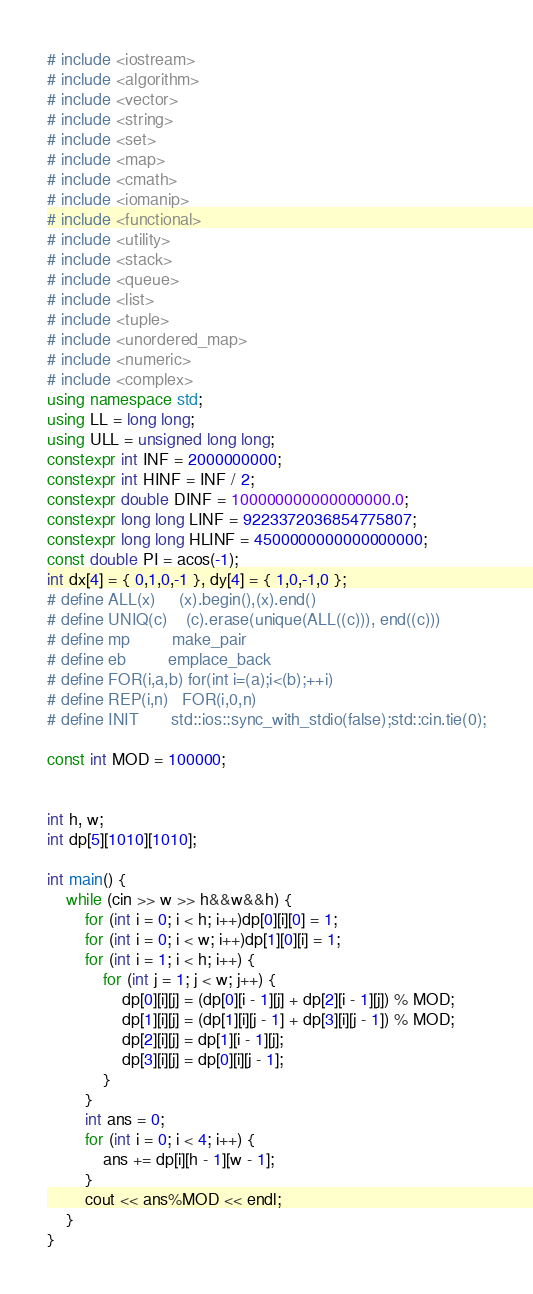Convert code to text. <code><loc_0><loc_0><loc_500><loc_500><_C++_># include <iostream>
# include <algorithm>
# include <vector>
# include <string>
# include <set>
# include <map>
# include <cmath>
# include <iomanip>
# include <functional>
# include <utility>
# include <stack>
# include <queue>
# include <list>
# include <tuple>
# include <unordered_map>
# include <numeric>
# include <complex>
using namespace std;
using LL = long long;
using ULL = unsigned long long;
constexpr int INF = 2000000000;
constexpr int HINF = INF / 2;
constexpr double DINF = 100000000000000000.0;
constexpr long long LINF = 9223372036854775807;
constexpr long long HLINF = 4500000000000000000;
const double PI = acos(-1);
int dx[4] = { 0,1,0,-1 }, dy[4] = { 1,0,-1,0 };
# define ALL(x)     (x).begin(),(x).end()
# define UNIQ(c)    (c).erase(unique(ALL((c))), end((c)))
# define mp         make_pair
# define eb         emplace_back
# define FOR(i,a,b) for(int i=(a);i<(b);++i)
# define REP(i,n)   FOR(i,0,n)
# define INIT       std::ios::sync_with_stdio(false);std::cin.tie(0);

const int MOD = 100000;


int h, w;
int dp[5][1010][1010];

int main() {
	while (cin >> w >> h&&w&&h) {
		for (int i = 0; i < h; i++)dp[0][i][0] = 1;
		for (int i = 0; i < w; i++)dp[1][0][i] = 1;
		for (int i = 1; i < h; i++) {
			for (int j = 1; j < w; j++) {
				dp[0][i][j] = (dp[0][i - 1][j] + dp[2][i - 1][j]) % MOD;
				dp[1][i][j] = (dp[1][i][j - 1] + dp[3][i][j - 1]) % MOD;
				dp[2][i][j] = dp[1][i - 1][j];
				dp[3][i][j] = dp[0][i][j - 1];
			}
		}
		int ans = 0;
		for (int i = 0; i < 4; i++) {
			ans += dp[i][h - 1][w - 1];
		}
		cout << ans%MOD << endl;
	}
}</code> 